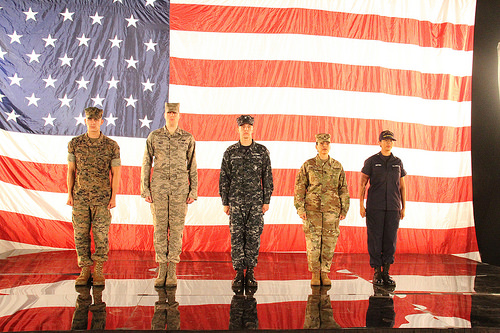<image>
Is the man on the flag? No. The man is not positioned on the flag. They may be near each other, but the man is not supported by or resting on top of the flag. Is the person in front of the flag? Yes. The person is positioned in front of the flag, appearing closer to the camera viewpoint. 